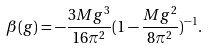Convert formula to latex. <formula><loc_0><loc_0><loc_500><loc_500>\beta ( g ) = - \frac { 3 M g ^ { 3 } } { 1 6 \pi ^ { 2 } } ( 1 - \frac { M g ^ { 2 } } { 8 \pi ^ { 2 } } ) ^ { - 1 } .</formula> 